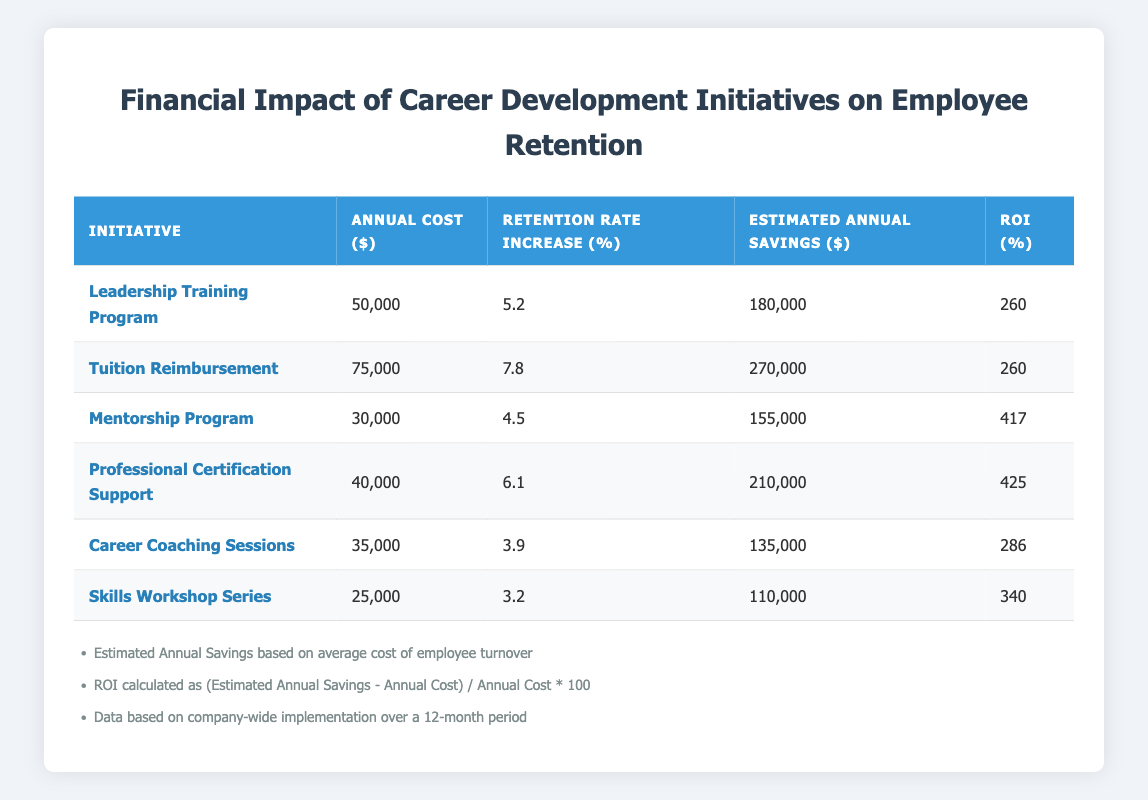What is the annual cost of the Leadership Training Program? The table lists the "Annual Cost ($)" for the Leadership Training Program as 50000. This information is found directly under the respective column for that initiative.
Answer: 50000 Which initiative has the highest percentage increase in retention rate? The "Retention Rate Increase (%)" column shows that the Tuition Reimbursement initiative has the highest increase at 7.8. This is the highest value when comparing all entries in that column.
Answer: 7.8 What is the average annual cost of all the initiatives listed? To find the average, sum the annual costs: 50000 + 75000 + 30000 + 40000 + 35000 + 25000 = 255000. There are 6 initiatives, so divide by 6: 255000 / 6 = 42500.
Answer: 42500 Is the ROI for the Professional Certification Support initiative higher than that for the Skills Workshop Series? The ROI for the Professional Certification Support initiative is 425, whereas the Skills Workshop Series has an ROI of 340. Since 425 is greater than 340, the statement is true.
Answer: Yes If we sum the estimated annual savings for all initiatives, what is the total? Adding the Estimated Annual Savings: 180000 + 270000 + 155000 + 210000 + 135000 + 110000 = 1065000. This sum represents the total estimated saving across all initiatives combined.
Answer: 1065000 Which initiative provides the lowest retention rate increase, and what is that percentage? The lowest retention rate increase is 3.2%, which corresponds to the Skills Workshop Series initiative. This is identified by comparing all values in the Retention Rate Increase (%) column.
Answer: Skills Workshop Series, 3.2% What is the difference in ROI between the Leadership Training Program and Career Coaching Sessions? The ROI for the Leadership Training Program is 260, and for Career Coaching Sessions, it is 286. The difference is 286 - 260 = 26. This shows how much more profitable the Career Coaching Sessions are relative to the Leadership Training Program.
Answer: 26 Is the estimated annual savings for the Mentorship Program less than that for the Leadership Training Program? The estimated annual savings for the Mentorship Program is 155000, and for the Leadership Training Program, it is 180000. Since 155000 is less than 180000, the answer is true.
Answer: Yes Which initiative has the highest return on investment percentage? By reviewing the ROI (%) column, the Professional Certification Support initiative has the highest ROI at 425%, indicating it generates the most return per dollar spent compared to the other initiatives.
Answer: 425 